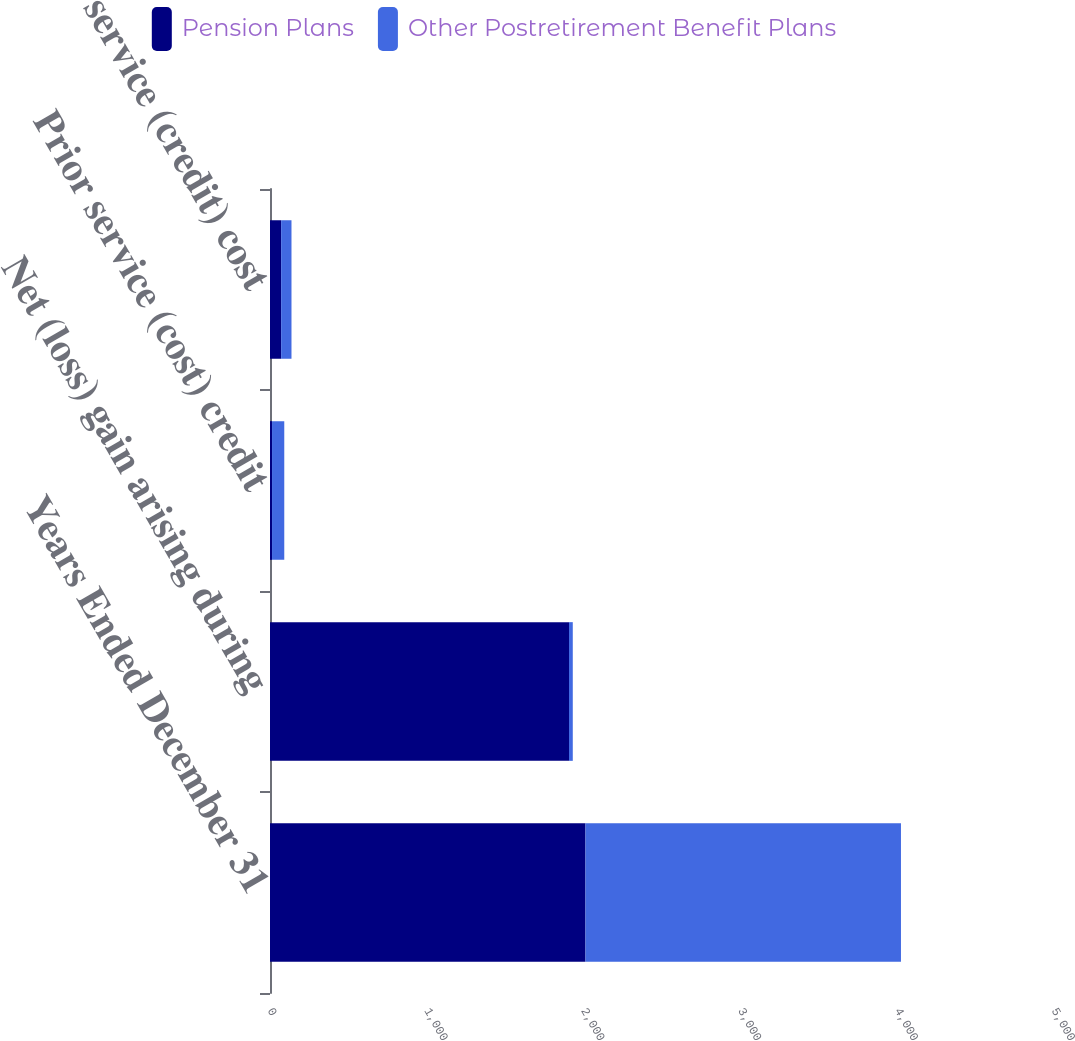Convert chart. <chart><loc_0><loc_0><loc_500><loc_500><stacked_bar_chart><ecel><fcel>Years Ended December 31<fcel>Net (loss) gain arising during<fcel>Prior service (cost) credit<fcel>Prior service (credit) cost<nl><fcel>Pension Plans<fcel>2012<fcel>1907<fcel>13<fcel>71<nl><fcel>Other Postretirement Benefit Plans<fcel>2012<fcel>24<fcel>78<fcel>66<nl></chart> 